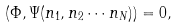Convert formula to latex. <formula><loc_0><loc_0><loc_500><loc_500>\left ( \Phi , \Psi ( n _ { 1 } , n _ { 2 } \cdots n _ { N } ) \right ) = 0 , \quad \\</formula> 